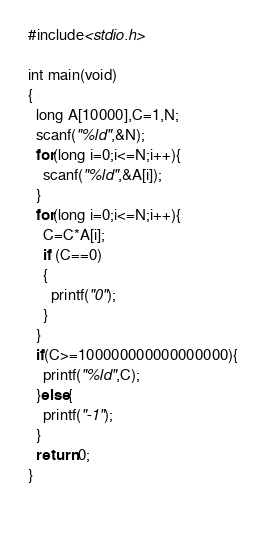Convert code to text. <code><loc_0><loc_0><loc_500><loc_500><_C_>#include<stdio.h>

int main(void)
{
  long A[10000],C=1,N;
  scanf("%ld",&N);
  for(long i=0;i<=N;i++){
    scanf("%ld",&A[i]);
  }
  for(long i=0;i<=N;i++){
    C=C*A[i];
    if (C==0)
    {
      printf("0");
    }
  } 
  if(C>=100000000000000000){
    printf("%ld",C);
  }else{
    printf("-1");
  }
  return 0;
}
  
</code> 